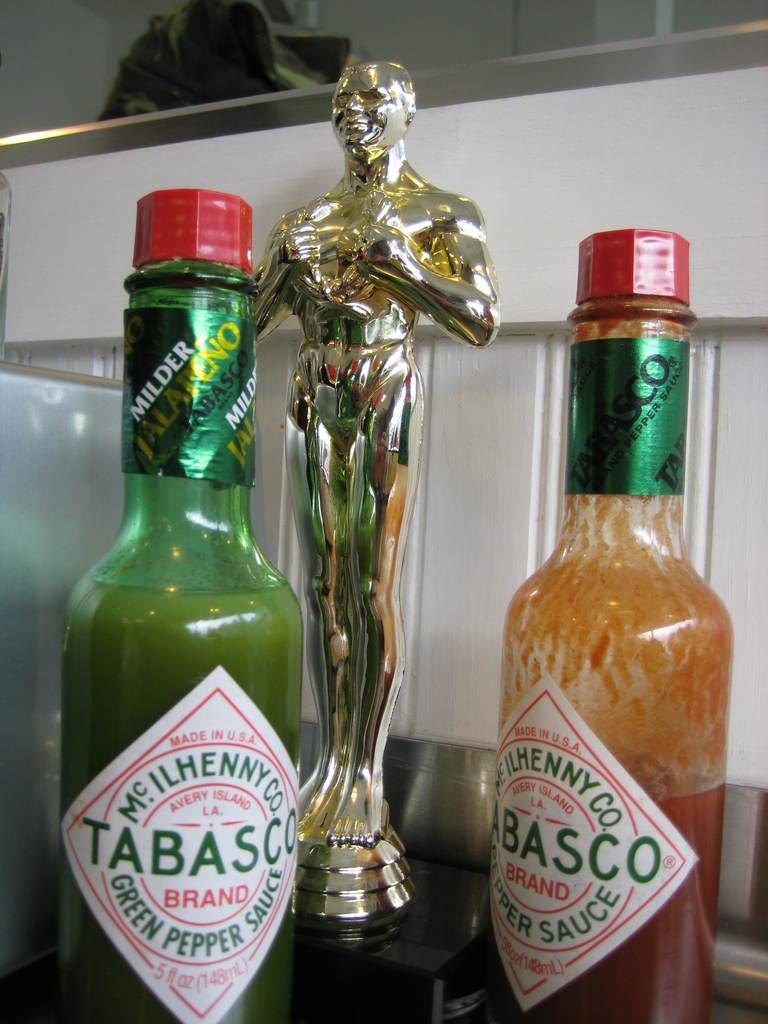Provide a one-sentence caption for the provided image. two bottles of tabasco standing next to each other. 